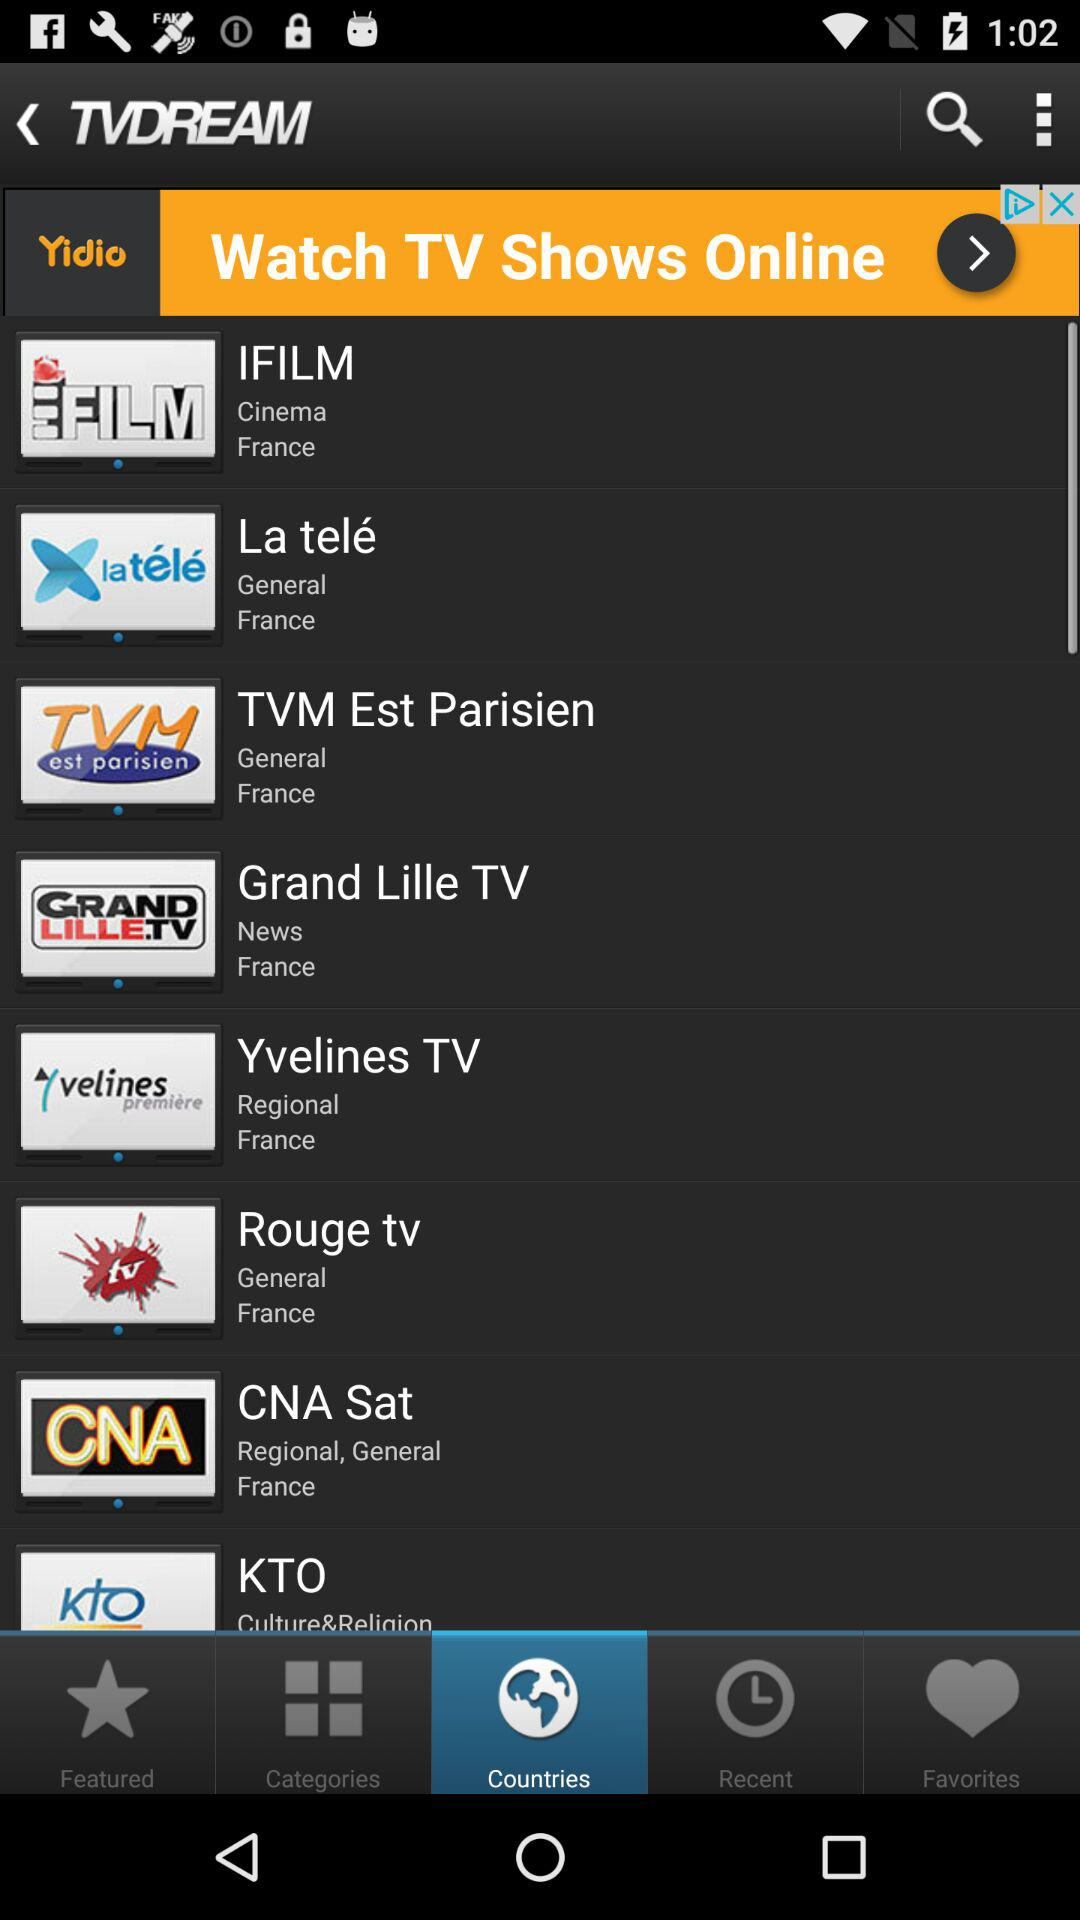What are the culture and religion channel names? The culture and religion channel name is "KTO". 